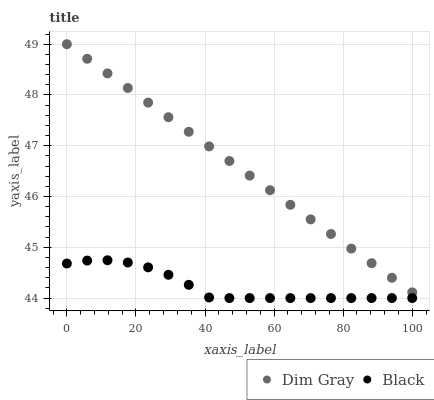Does Black have the minimum area under the curve?
Answer yes or no. Yes. Does Dim Gray have the maximum area under the curve?
Answer yes or no. Yes. Does Black have the maximum area under the curve?
Answer yes or no. No. Is Dim Gray the smoothest?
Answer yes or no. Yes. Is Black the roughest?
Answer yes or no. Yes. Is Black the smoothest?
Answer yes or no. No. Does Black have the lowest value?
Answer yes or no. Yes. Does Dim Gray have the highest value?
Answer yes or no. Yes. Does Black have the highest value?
Answer yes or no. No. Is Black less than Dim Gray?
Answer yes or no. Yes. Is Dim Gray greater than Black?
Answer yes or no. Yes. Does Black intersect Dim Gray?
Answer yes or no. No. 